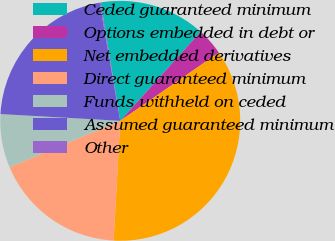Convert chart. <chart><loc_0><loc_0><loc_500><loc_500><pie_chart><fcel>Ceded guaranteed minimum<fcel>Options embedded in debt or<fcel>Net embedded derivatives<fcel>Direct guaranteed minimum<fcel>Funds withheld on ceded<fcel>Assumed guaranteed minimum<fcel>Other<nl><fcel>14.29%<fcel>3.68%<fcel>35.51%<fcel>17.82%<fcel>7.21%<fcel>21.36%<fcel>0.14%<nl></chart> 